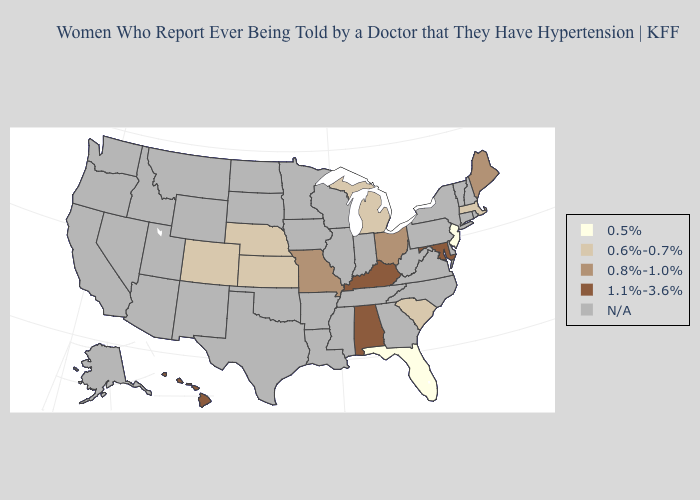What is the lowest value in the USA?
Be succinct. 0.5%. Does the first symbol in the legend represent the smallest category?
Keep it brief. Yes. Among the states that border Delaware , does Maryland have the lowest value?
Give a very brief answer. No. Among the states that border Kansas , does Missouri have the lowest value?
Answer briefly. No. Name the states that have a value in the range 0.8%-1.0%?
Short answer required. Maine, Missouri, Ohio. Does South Carolina have the highest value in the South?
Write a very short answer. No. What is the value of Connecticut?
Quick response, please. N/A. What is the highest value in states that border Alabama?
Write a very short answer. 0.5%. What is the value of Rhode Island?
Write a very short answer. N/A. Name the states that have a value in the range 0.5%?
Give a very brief answer. Florida, New Jersey. Does Colorado have the highest value in the West?
Give a very brief answer. No. Name the states that have a value in the range 0.8%-1.0%?
Answer briefly. Maine, Missouri, Ohio. What is the highest value in the USA?
Short answer required. 1.1%-3.6%. Name the states that have a value in the range 0.8%-1.0%?
Short answer required. Maine, Missouri, Ohio. 